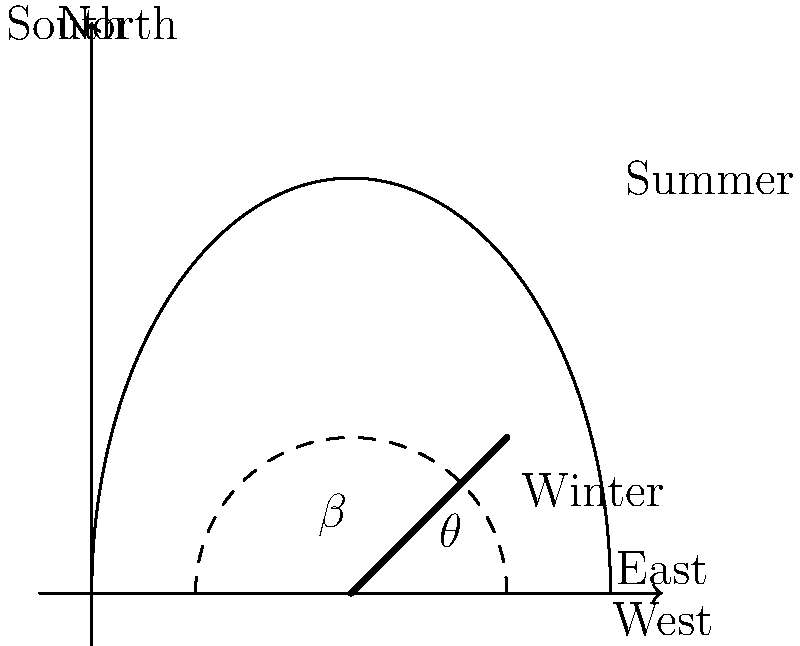As a B20 representative working with solar energy projects, you're tasked with determining the optimal tilt angle for a fixed solar panel installation at a latitude of 40°N. Using the provided sun path diagram, what is the best year-round tilt angle $\theta$ for the solar panel to maximize annual energy production? To determine the optimal tilt angle for a fixed solar panel, we need to consider the following steps:

1. Understand the sun's path: The diagram shows the sun's path during summer (higher arc) and winter (lower arc).

2. Consider the latitude: At 40°N, the sun's elevation changes significantly between seasons.

3. Analyze the midday sun position: The optimal angle is often close to the average midday sun elevation throughout the year.

4. Calculate the complement of the latitude: A good rule of thumb is to set the tilt angle equal to the latitude for year-round optimization. The panel angle $\theta$ is the complement of the tilt angle $\beta$.

5. Apply the rule: $\beta = \text{latitude} = 40°$

6. Calculate the panel angle: $\theta = 90° - \beta = 90° - 40° = 50°$

This angle ensures that the panel is perpendicular to the sun's rays during the equinoxes (spring and fall), providing a good compromise between summer and winter performance.

7. Verify with the diagram: The 50° angle appears to be a good middle ground between the summer and winter sun paths, confirming our calculation.
Answer: 50° 